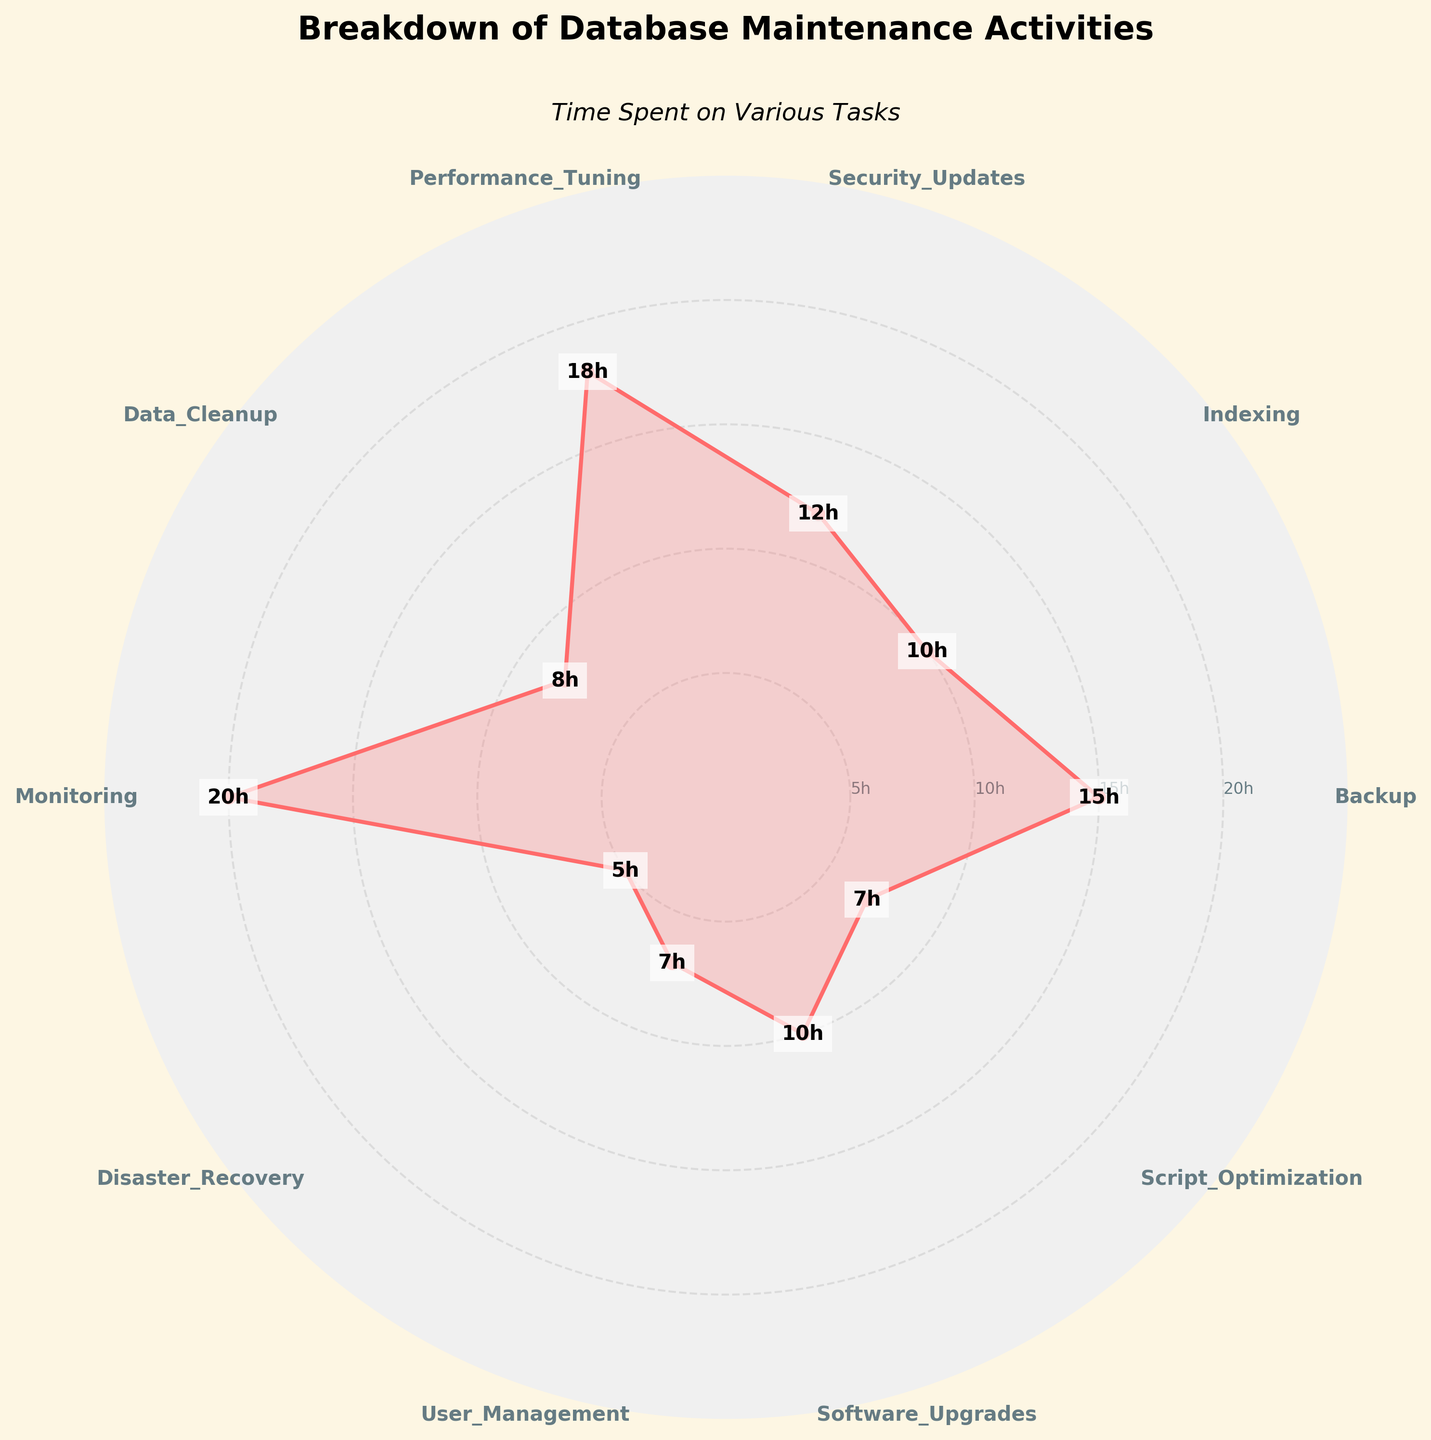What is the activity that takes the most time? The activity that takes the most time can be identified by seeing which segment of the rose chart has the largest radial distance. Monitoring has the largest segment, reaching 20 hours.
Answer: Monitoring Which two activities have the same amount of time spent on them? Comparing the radial distances of the segments, Software Upgrades and Indexing both have a radial label showing 10 hours, indicating that they take the same amount of time.
Answer: Software Upgrades and Indexing How many total hours are spent on Performance Tuning and User Management combined? Performance Tuning takes 18 hours and User Management takes 7 hours. Summing these values gives \( 18 + 7 = 25 \) hours.
Answer: 25 hours What is the difference in time spent between Data Cleanup and Disaster Recovery? Data Cleanup takes 8 hours and Disaster Recovery takes 5 hours. The difference between these values is \( 8 - 5 = 3 \) hours.
Answer: 3 hours How many activities take up more than 10 hours? From the rose chart, the activities that exceed 10 hours are Backup (15), Security Updates (12), Performance Tuning (18), and Monitoring (20). Four activities take more than 10 hours.
Answer: 4 Between Security Updates and Script Optimization, which takes more time? Comparing the radial distances of the segments, Security Updates take 12 hours, and Script Optimization takes 7 hours. Therefore, Security Updates take more time.
Answer: Security Updates What is the total time spent on all database maintenance activities? Adding up all the hours for each activity: \( 15 + 10 + 12 + 18 + 8 + 20 + 5 + 7 + 10 + 7 = 112 \) hours.
Answer: 112 hours Which activities take less than 10 hours? Observing the radial distances, the activities that take less than 10 hours are Data Cleanup (8), Disaster Recovery (5), User Management (7), and Script Optimization (7).
Answer: Data Cleanup, Disaster Recovery, User Management, Script Optimization What is the average time spent on all activities? Total time spent on all activities is 112 hours, and there are 10 activities. Therefore, the average time is \( \frac{112}{10} = 11.2 \) hours.
Answer: 11.2 hours 